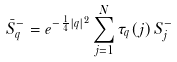Convert formula to latex. <formula><loc_0><loc_0><loc_500><loc_500>\bar { S } _ { q } ^ { - } = e ^ { - \frac { 1 } { 4 } | q | ^ { 2 } } \sum _ { j = 1 } ^ { N } \tau _ { q } ( j ) \, S _ { j } ^ { - }</formula> 